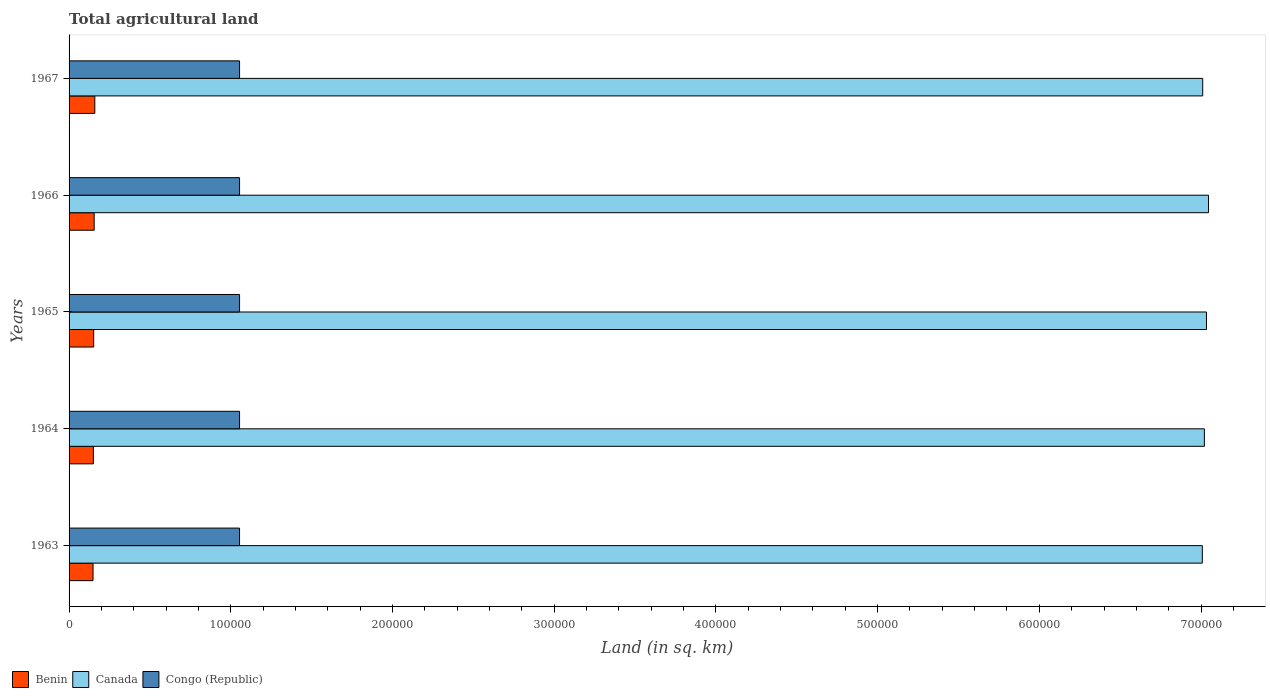How many groups of bars are there?
Give a very brief answer. 5. Are the number of bars on each tick of the Y-axis equal?
Give a very brief answer. Yes. How many bars are there on the 5th tick from the top?
Your response must be concise. 3. What is the label of the 1st group of bars from the top?
Offer a terse response. 1967. In how many cases, is the number of bars for a given year not equal to the number of legend labels?
Your answer should be compact. 0. What is the total agricultural land in Benin in 1965?
Make the answer very short. 1.52e+04. Across all years, what is the maximum total agricultural land in Congo (Republic)?
Your answer should be very brief. 1.05e+05. Across all years, what is the minimum total agricultural land in Congo (Republic)?
Provide a short and direct response. 1.05e+05. In which year was the total agricultural land in Congo (Republic) maximum?
Make the answer very short. 1964. What is the total total agricultural land in Congo (Republic) in the graph?
Give a very brief answer. 5.27e+05. What is the difference between the total agricultural land in Congo (Republic) in 1963 and that in 1964?
Your response must be concise. -10. What is the difference between the total agricultural land in Canada in 1967 and the total agricultural land in Congo (Republic) in 1963?
Your answer should be very brief. 5.96e+05. What is the average total agricultural land in Canada per year?
Make the answer very short. 7.02e+05. In the year 1964, what is the difference between the total agricultural land in Canada and total agricultural land in Congo (Republic)?
Give a very brief answer. 5.97e+05. In how many years, is the total agricultural land in Canada greater than 360000 sq.km?
Ensure brevity in your answer.  5. What is the ratio of the total agricultural land in Congo (Republic) in 1965 to that in 1967?
Provide a succinct answer. 1. Is the difference between the total agricultural land in Canada in 1964 and 1967 greater than the difference between the total agricultural land in Congo (Republic) in 1964 and 1967?
Give a very brief answer. Yes. What is the difference between the highest and the lowest total agricultural land in Benin?
Offer a very short reply. 1100. Is the sum of the total agricultural land in Benin in 1964 and 1967 greater than the maximum total agricultural land in Canada across all years?
Offer a very short reply. No. What does the 1st bar from the top in 1966 represents?
Provide a succinct answer. Congo (Republic). What does the 3rd bar from the bottom in 1967 represents?
Your response must be concise. Congo (Republic). Is it the case that in every year, the sum of the total agricultural land in Benin and total agricultural land in Congo (Republic) is greater than the total agricultural land in Canada?
Provide a short and direct response. No. How many years are there in the graph?
Your answer should be compact. 5. Are the values on the major ticks of X-axis written in scientific E-notation?
Your response must be concise. No. Where does the legend appear in the graph?
Offer a very short reply. Bottom left. How are the legend labels stacked?
Offer a very short reply. Horizontal. What is the title of the graph?
Provide a short and direct response. Total agricultural land. Does "Kiribati" appear as one of the legend labels in the graph?
Your answer should be compact. No. What is the label or title of the X-axis?
Offer a very short reply. Land (in sq. km). What is the Land (in sq. km) of Benin in 1963?
Give a very brief answer. 1.48e+04. What is the Land (in sq. km) of Canada in 1963?
Provide a succinct answer. 7.01e+05. What is the Land (in sq. km) in Congo (Republic) in 1963?
Offer a terse response. 1.05e+05. What is the Land (in sq. km) of Benin in 1964?
Provide a short and direct response. 1.50e+04. What is the Land (in sq. km) of Canada in 1964?
Give a very brief answer. 7.02e+05. What is the Land (in sq. km) of Congo (Republic) in 1964?
Your response must be concise. 1.05e+05. What is the Land (in sq. km) of Benin in 1965?
Provide a succinct answer. 1.52e+04. What is the Land (in sq. km) of Canada in 1965?
Provide a succinct answer. 7.03e+05. What is the Land (in sq. km) in Congo (Republic) in 1965?
Keep it short and to the point. 1.05e+05. What is the Land (in sq. km) of Benin in 1966?
Offer a terse response. 1.55e+04. What is the Land (in sq. km) of Canada in 1966?
Ensure brevity in your answer.  7.05e+05. What is the Land (in sq. km) in Congo (Republic) in 1966?
Give a very brief answer. 1.05e+05. What is the Land (in sq. km) of Benin in 1967?
Offer a very short reply. 1.59e+04. What is the Land (in sq. km) of Canada in 1967?
Your response must be concise. 7.01e+05. What is the Land (in sq. km) in Congo (Republic) in 1967?
Keep it short and to the point. 1.05e+05. Across all years, what is the maximum Land (in sq. km) of Benin?
Provide a succinct answer. 1.59e+04. Across all years, what is the maximum Land (in sq. km) in Canada?
Your response must be concise. 7.05e+05. Across all years, what is the maximum Land (in sq. km) in Congo (Republic)?
Keep it short and to the point. 1.05e+05. Across all years, what is the minimum Land (in sq. km) of Benin?
Make the answer very short. 1.48e+04. Across all years, what is the minimum Land (in sq. km) of Canada?
Offer a very short reply. 7.01e+05. Across all years, what is the minimum Land (in sq. km) in Congo (Republic)?
Ensure brevity in your answer.  1.05e+05. What is the total Land (in sq. km) of Benin in the graph?
Offer a terse response. 7.65e+04. What is the total Land (in sq. km) of Canada in the graph?
Your answer should be compact. 3.51e+06. What is the total Land (in sq. km) of Congo (Republic) in the graph?
Give a very brief answer. 5.27e+05. What is the difference between the Land (in sq. km) of Benin in 1963 and that in 1964?
Your answer should be very brief. -200. What is the difference between the Land (in sq. km) of Canada in 1963 and that in 1964?
Ensure brevity in your answer.  -1270. What is the difference between the Land (in sq. km) in Benin in 1963 and that in 1965?
Provide a succinct answer. -400. What is the difference between the Land (in sq. km) of Canada in 1963 and that in 1965?
Give a very brief answer. -2560. What is the difference between the Land (in sq. km) in Benin in 1963 and that in 1966?
Your answer should be compact. -700. What is the difference between the Land (in sq. km) in Canada in 1963 and that in 1966?
Make the answer very short. -3830. What is the difference between the Land (in sq. km) in Benin in 1963 and that in 1967?
Ensure brevity in your answer.  -1100. What is the difference between the Land (in sq. km) of Canada in 1963 and that in 1967?
Ensure brevity in your answer.  -230. What is the difference between the Land (in sq. km) of Congo (Republic) in 1963 and that in 1967?
Give a very brief answer. -10. What is the difference between the Land (in sq. km) of Benin in 1964 and that in 1965?
Your answer should be very brief. -200. What is the difference between the Land (in sq. km) in Canada in 1964 and that in 1965?
Offer a terse response. -1290. What is the difference between the Land (in sq. km) in Benin in 1964 and that in 1966?
Keep it short and to the point. -500. What is the difference between the Land (in sq. km) of Canada in 1964 and that in 1966?
Your answer should be compact. -2560. What is the difference between the Land (in sq. km) in Congo (Republic) in 1964 and that in 1966?
Provide a succinct answer. 0. What is the difference between the Land (in sq. km) of Benin in 1964 and that in 1967?
Your answer should be very brief. -900. What is the difference between the Land (in sq. km) of Canada in 1964 and that in 1967?
Your response must be concise. 1040. What is the difference between the Land (in sq. km) in Benin in 1965 and that in 1966?
Ensure brevity in your answer.  -300. What is the difference between the Land (in sq. km) in Canada in 1965 and that in 1966?
Make the answer very short. -1270. What is the difference between the Land (in sq. km) of Congo (Republic) in 1965 and that in 1966?
Your answer should be very brief. 0. What is the difference between the Land (in sq. km) in Benin in 1965 and that in 1967?
Give a very brief answer. -700. What is the difference between the Land (in sq. km) of Canada in 1965 and that in 1967?
Offer a terse response. 2330. What is the difference between the Land (in sq. km) in Congo (Republic) in 1965 and that in 1967?
Your response must be concise. 0. What is the difference between the Land (in sq. km) in Benin in 1966 and that in 1967?
Your response must be concise. -400. What is the difference between the Land (in sq. km) of Canada in 1966 and that in 1967?
Give a very brief answer. 3600. What is the difference between the Land (in sq. km) in Congo (Republic) in 1966 and that in 1967?
Give a very brief answer. 0. What is the difference between the Land (in sq. km) of Benin in 1963 and the Land (in sq. km) of Canada in 1964?
Offer a very short reply. -6.87e+05. What is the difference between the Land (in sq. km) of Benin in 1963 and the Land (in sq. km) of Congo (Republic) in 1964?
Your answer should be compact. -9.06e+04. What is the difference between the Land (in sq. km) in Canada in 1963 and the Land (in sq. km) in Congo (Republic) in 1964?
Ensure brevity in your answer.  5.95e+05. What is the difference between the Land (in sq. km) of Benin in 1963 and the Land (in sq. km) of Canada in 1965?
Keep it short and to the point. -6.89e+05. What is the difference between the Land (in sq. km) of Benin in 1963 and the Land (in sq. km) of Congo (Republic) in 1965?
Keep it short and to the point. -9.06e+04. What is the difference between the Land (in sq. km) of Canada in 1963 and the Land (in sq. km) of Congo (Republic) in 1965?
Offer a terse response. 5.95e+05. What is the difference between the Land (in sq. km) in Benin in 1963 and the Land (in sq. km) in Canada in 1966?
Make the answer very short. -6.90e+05. What is the difference between the Land (in sq. km) in Benin in 1963 and the Land (in sq. km) in Congo (Republic) in 1966?
Provide a short and direct response. -9.06e+04. What is the difference between the Land (in sq. km) in Canada in 1963 and the Land (in sq. km) in Congo (Republic) in 1966?
Give a very brief answer. 5.95e+05. What is the difference between the Land (in sq. km) in Benin in 1963 and the Land (in sq. km) in Canada in 1967?
Keep it short and to the point. -6.86e+05. What is the difference between the Land (in sq. km) of Benin in 1963 and the Land (in sq. km) of Congo (Republic) in 1967?
Your response must be concise. -9.06e+04. What is the difference between the Land (in sq. km) of Canada in 1963 and the Land (in sq. km) of Congo (Republic) in 1967?
Your response must be concise. 5.95e+05. What is the difference between the Land (in sq. km) in Benin in 1964 and the Land (in sq. km) in Canada in 1965?
Your response must be concise. -6.88e+05. What is the difference between the Land (in sq. km) in Benin in 1964 and the Land (in sq. km) in Congo (Republic) in 1965?
Your answer should be very brief. -9.04e+04. What is the difference between the Land (in sq. km) in Canada in 1964 and the Land (in sq. km) in Congo (Republic) in 1965?
Keep it short and to the point. 5.97e+05. What is the difference between the Land (in sq. km) of Benin in 1964 and the Land (in sq. km) of Canada in 1966?
Offer a very short reply. -6.90e+05. What is the difference between the Land (in sq. km) in Benin in 1964 and the Land (in sq. km) in Congo (Republic) in 1966?
Your answer should be compact. -9.04e+04. What is the difference between the Land (in sq. km) in Canada in 1964 and the Land (in sq. km) in Congo (Republic) in 1966?
Your answer should be very brief. 5.97e+05. What is the difference between the Land (in sq. km) of Benin in 1964 and the Land (in sq. km) of Canada in 1967?
Make the answer very short. -6.86e+05. What is the difference between the Land (in sq. km) in Benin in 1964 and the Land (in sq. km) in Congo (Republic) in 1967?
Provide a succinct answer. -9.04e+04. What is the difference between the Land (in sq. km) in Canada in 1964 and the Land (in sq. km) in Congo (Republic) in 1967?
Offer a terse response. 5.97e+05. What is the difference between the Land (in sq. km) of Benin in 1965 and the Land (in sq. km) of Canada in 1966?
Make the answer very short. -6.89e+05. What is the difference between the Land (in sq. km) in Benin in 1965 and the Land (in sq. km) in Congo (Republic) in 1966?
Make the answer very short. -9.02e+04. What is the difference between the Land (in sq. km) in Canada in 1965 and the Land (in sq. km) in Congo (Republic) in 1966?
Provide a succinct answer. 5.98e+05. What is the difference between the Land (in sq. km) of Benin in 1965 and the Land (in sq. km) of Canada in 1967?
Your answer should be very brief. -6.86e+05. What is the difference between the Land (in sq. km) of Benin in 1965 and the Land (in sq. km) of Congo (Republic) in 1967?
Give a very brief answer. -9.02e+04. What is the difference between the Land (in sq. km) in Canada in 1965 and the Land (in sq. km) in Congo (Republic) in 1967?
Your answer should be compact. 5.98e+05. What is the difference between the Land (in sq. km) of Benin in 1966 and the Land (in sq. km) of Canada in 1967?
Your response must be concise. -6.86e+05. What is the difference between the Land (in sq. km) of Benin in 1966 and the Land (in sq. km) of Congo (Republic) in 1967?
Provide a succinct answer. -8.99e+04. What is the difference between the Land (in sq. km) in Canada in 1966 and the Land (in sq. km) in Congo (Republic) in 1967?
Provide a short and direct response. 5.99e+05. What is the average Land (in sq. km) in Benin per year?
Your answer should be compact. 1.53e+04. What is the average Land (in sq. km) in Canada per year?
Provide a short and direct response. 7.02e+05. What is the average Land (in sq. km) in Congo (Republic) per year?
Ensure brevity in your answer.  1.05e+05. In the year 1963, what is the difference between the Land (in sq. km) of Benin and Land (in sq. km) of Canada?
Offer a terse response. -6.86e+05. In the year 1963, what is the difference between the Land (in sq. km) of Benin and Land (in sq. km) of Congo (Republic)?
Offer a very short reply. -9.06e+04. In the year 1963, what is the difference between the Land (in sq. km) of Canada and Land (in sq. km) of Congo (Republic)?
Your response must be concise. 5.95e+05. In the year 1964, what is the difference between the Land (in sq. km) of Benin and Land (in sq. km) of Canada?
Offer a terse response. -6.87e+05. In the year 1964, what is the difference between the Land (in sq. km) of Benin and Land (in sq. km) of Congo (Republic)?
Your response must be concise. -9.04e+04. In the year 1964, what is the difference between the Land (in sq. km) of Canada and Land (in sq. km) of Congo (Republic)?
Your response must be concise. 5.97e+05. In the year 1965, what is the difference between the Land (in sq. km) of Benin and Land (in sq. km) of Canada?
Keep it short and to the point. -6.88e+05. In the year 1965, what is the difference between the Land (in sq. km) in Benin and Land (in sq. km) in Congo (Republic)?
Provide a short and direct response. -9.02e+04. In the year 1965, what is the difference between the Land (in sq. km) of Canada and Land (in sq. km) of Congo (Republic)?
Provide a short and direct response. 5.98e+05. In the year 1966, what is the difference between the Land (in sq. km) in Benin and Land (in sq. km) in Canada?
Make the answer very short. -6.89e+05. In the year 1966, what is the difference between the Land (in sq. km) of Benin and Land (in sq. km) of Congo (Republic)?
Offer a very short reply. -8.99e+04. In the year 1966, what is the difference between the Land (in sq. km) of Canada and Land (in sq. km) of Congo (Republic)?
Your answer should be compact. 5.99e+05. In the year 1967, what is the difference between the Land (in sq. km) of Benin and Land (in sq. km) of Canada?
Give a very brief answer. -6.85e+05. In the year 1967, what is the difference between the Land (in sq. km) in Benin and Land (in sq. km) in Congo (Republic)?
Offer a very short reply. -8.95e+04. In the year 1967, what is the difference between the Land (in sq. km) of Canada and Land (in sq. km) of Congo (Republic)?
Your answer should be very brief. 5.96e+05. What is the ratio of the Land (in sq. km) in Benin in 1963 to that in 1964?
Your answer should be very brief. 0.99. What is the ratio of the Land (in sq. km) in Canada in 1963 to that in 1964?
Give a very brief answer. 1. What is the ratio of the Land (in sq. km) in Benin in 1963 to that in 1965?
Give a very brief answer. 0.97. What is the ratio of the Land (in sq. km) of Canada in 1963 to that in 1965?
Give a very brief answer. 1. What is the ratio of the Land (in sq. km) of Congo (Republic) in 1963 to that in 1965?
Give a very brief answer. 1. What is the ratio of the Land (in sq. km) of Benin in 1963 to that in 1966?
Your answer should be compact. 0.95. What is the ratio of the Land (in sq. km) of Benin in 1963 to that in 1967?
Provide a short and direct response. 0.93. What is the ratio of the Land (in sq. km) in Congo (Republic) in 1963 to that in 1967?
Provide a short and direct response. 1. What is the ratio of the Land (in sq. km) in Benin in 1964 to that in 1965?
Offer a terse response. 0.99. What is the ratio of the Land (in sq. km) of Canada in 1964 to that in 1965?
Ensure brevity in your answer.  1. What is the ratio of the Land (in sq. km) of Congo (Republic) in 1964 to that in 1965?
Your response must be concise. 1. What is the ratio of the Land (in sq. km) in Benin in 1964 to that in 1966?
Your answer should be very brief. 0.97. What is the ratio of the Land (in sq. km) of Canada in 1964 to that in 1966?
Make the answer very short. 1. What is the ratio of the Land (in sq. km) in Benin in 1964 to that in 1967?
Make the answer very short. 0.94. What is the ratio of the Land (in sq. km) in Congo (Republic) in 1964 to that in 1967?
Your response must be concise. 1. What is the ratio of the Land (in sq. km) in Benin in 1965 to that in 1966?
Ensure brevity in your answer.  0.98. What is the ratio of the Land (in sq. km) in Benin in 1965 to that in 1967?
Provide a short and direct response. 0.96. What is the ratio of the Land (in sq. km) of Canada in 1965 to that in 1967?
Offer a very short reply. 1. What is the ratio of the Land (in sq. km) of Congo (Republic) in 1965 to that in 1967?
Your response must be concise. 1. What is the ratio of the Land (in sq. km) of Benin in 1966 to that in 1967?
Make the answer very short. 0.97. What is the ratio of the Land (in sq. km) in Canada in 1966 to that in 1967?
Make the answer very short. 1.01. What is the ratio of the Land (in sq. km) in Congo (Republic) in 1966 to that in 1967?
Give a very brief answer. 1. What is the difference between the highest and the second highest Land (in sq. km) of Canada?
Offer a terse response. 1270. What is the difference between the highest and the second highest Land (in sq. km) of Congo (Republic)?
Ensure brevity in your answer.  0. What is the difference between the highest and the lowest Land (in sq. km) in Benin?
Provide a short and direct response. 1100. What is the difference between the highest and the lowest Land (in sq. km) in Canada?
Ensure brevity in your answer.  3830. What is the difference between the highest and the lowest Land (in sq. km) in Congo (Republic)?
Give a very brief answer. 10. 